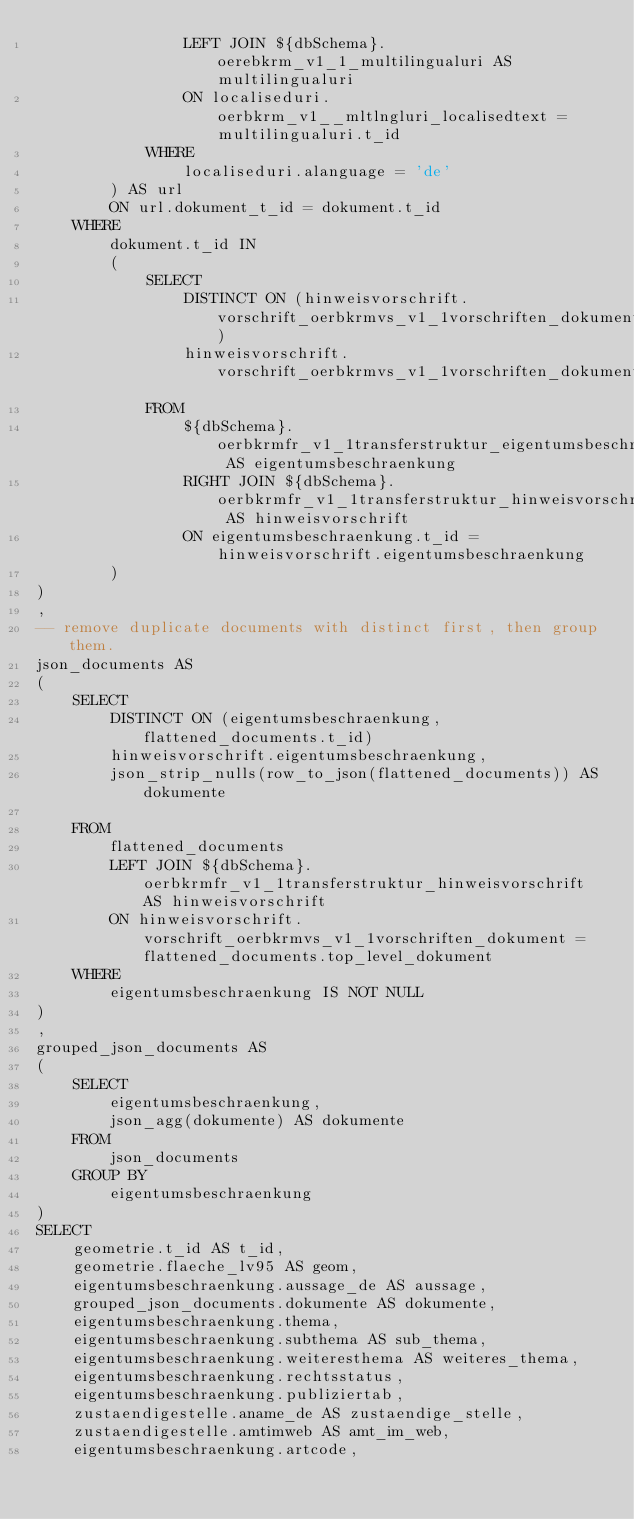<code> <loc_0><loc_0><loc_500><loc_500><_SQL_>                LEFT JOIN ${dbSchema}.oerebkrm_v1_1_multilingualuri AS multilingualuri
                ON localiseduri.oerbkrm_v1__mltlngluri_localisedtext = multilingualuri.t_id
            WHERE
                localiseduri.alanguage = 'de'
        ) AS url
        ON url.dokument_t_id = dokument.t_id
    WHERE
        dokument.t_id IN 
        (
            SELECT 
                DISTINCT ON (hinweisvorschrift.vorschrift_oerbkrmvs_v1_1vorschriften_dokument)
                hinweisvorschrift.vorschrift_oerbkrmvs_v1_1vorschriften_dokument
            FROM
                ${dbSchema}.oerbkrmfr_v1_1transferstruktur_eigentumsbeschraenkung AS eigentumsbeschraenkung
                RIGHT JOIN ${dbSchema}.oerbkrmfr_v1_1transferstruktur_hinweisvorschrift AS hinweisvorschrift
                ON eigentumsbeschraenkung.t_id = hinweisvorschrift.eigentumsbeschraenkung
        )
)
,
-- remove duplicate documents with distinct first, then group them.
json_documents AS 
(
    SELECT
        DISTINCT ON (eigentumsbeschraenkung, flattened_documents.t_id)
        hinweisvorschrift.eigentumsbeschraenkung,
        json_strip_nulls(row_to_json(flattened_documents)) AS dokumente
        
    FROM  
        flattened_documents
        LEFT JOIN ${dbSchema}.oerbkrmfr_v1_1transferstruktur_hinweisvorschrift AS hinweisvorschrift
        ON hinweisvorschrift.vorschrift_oerbkrmvs_v1_1vorschriften_dokument = flattened_documents.top_level_dokument
    WHERE
        eigentumsbeschraenkung IS NOT NULL
)
,
grouped_json_documents AS
(
    SELECT
        eigentumsbeschraenkung,
        json_agg(dokumente) AS dokumente
    FROM
        json_documents
    GROUP BY
        eigentumsbeschraenkung
)
SELECT
    geometrie.t_id AS t_id,
    geometrie.flaeche_lv95 AS geom,
    eigentumsbeschraenkung.aussage_de AS aussage,
    grouped_json_documents.dokumente AS dokumente,
    eigentumsbeschraenkung.thema,
    eigentumsbeschraenkung.subthema AS sub_thema,
    eigentumsbeschraenkung.weiteresthema AS weiteres_thema,
    eigentumsbeschraenkung.rechtsstatus,
    eigentumsbeschraenkung.publiziertab,
    zustaendigestelle.aname_de AS zustaendige_stelle,
    zustaendigestelle.amtimweb AS amt_im_web,
    eigentumsbeschraenkung.artcode,</code> 